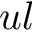<formula> <loc_0><loc_0><loc_500><loc_500>u l</formula> 